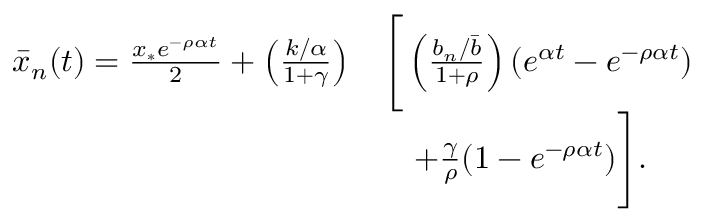<formula> <loc_0><loc_0><loc_500><loc_500>\begin{array} { r l } { \bar { x } _ { n } ( t ) = \frac { x _ { * } e ^ { - \rho \alpha t } } { 2 } + \left ( \frac { k / \alpha } { 1 + \gamma } \right ) } & { \left [ \left ( \frac { b _ { n } / \bar { b } } { 1 + \rho } \right ) ( e ^ { \alpha t } - e ^ { - \rho \alpha t } ) } \\ & { \quad + \frac { \gamma } { \rho } ( 1 - e ^ { - \rho \alpha t } ) \right ] . } \end{array}</formula> 